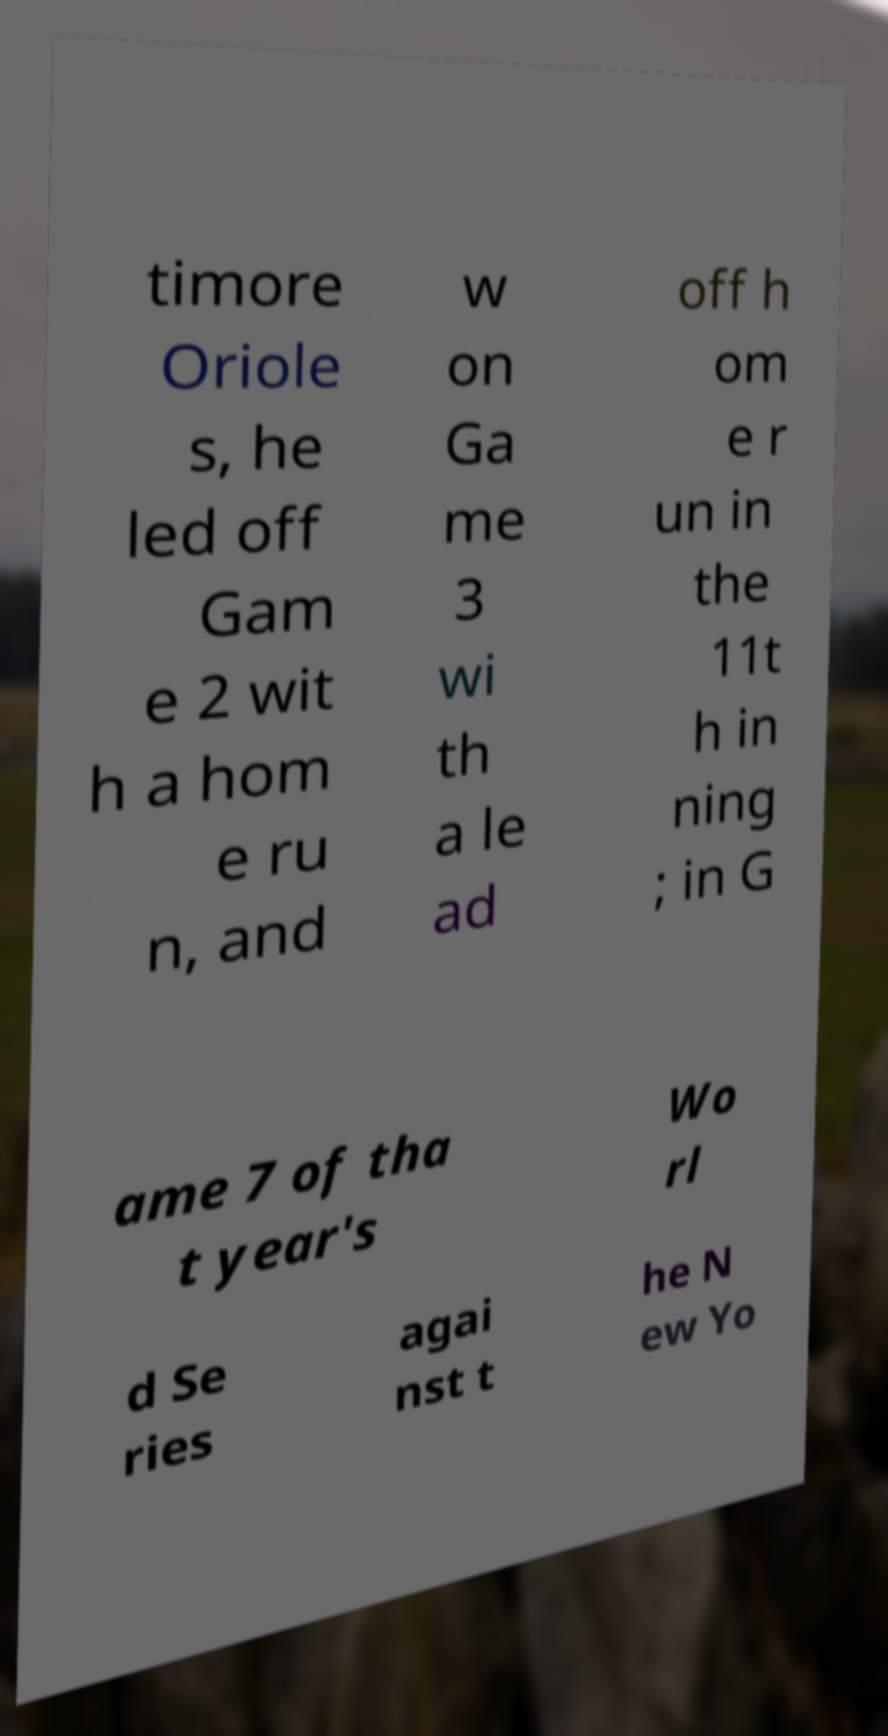What messages or text are displayed in this image? I need them in a readable, typed format. timore Oriole s, he led off Gam e 2 wit h a hom e ru n, and w on Ga me 3 wi th a le ad off h om e r un in the 11t h in ning ; in G ame 7 of tha t year's Wo rl d Se ries agai nst t he N ew Yo 